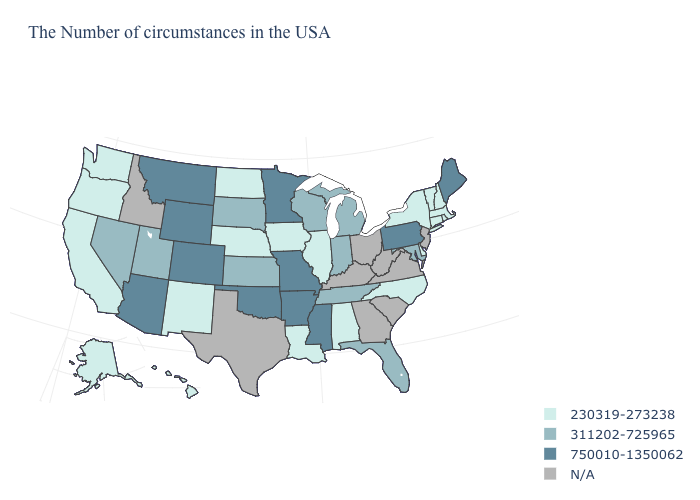Does Maine have the highest value in the Northeast?
Short answer required. Yes. What is the value of Maryland?
Give a very brief answer. 311202-725965. Name the states that have a value in the range 230319-273238?
Quick response, please. Massachusetts, Rhode Island, New Hampshire, Vermont, Connecticut, New York, Delaware, North Carolina, Alabama, Illinois, Louisiana, Iowa, Nebraska, North Dakota, New Mexico, California, Washington, Oregon, Alaska, Hawaii. Among the states that border Indiana , which have the lowest value?
Write a very short answer. Illinois. Does Nebraska have the lowest value in the MidWest?
Short answer required. Yes. Does Washington have the highest value in the West?
Short answer required. No. Name the states that have a value in the range N/A?
Short answer required. New Jersey, Virginia, South Carolina, West Virginia, Ohio, Georgia, Kentucky, Texas, Idaho. Which states have the lowest value in the USA?
Write a very short answer. Massachusetts, Rhode Island, New Hampshire, Vermont, Connecticut, New York, Delaware, North Carolina, Alabama, Illinois, Louisiana, Iowa, Nebraska, North Dakota, New Mexico, California, Washington, Oregon, Alaska, Hawaii. What is the value of Montana?
Be succinct. 750010-1350062. Among the states that border Oregon , which have the highest value?
Be succinct. Nevada. Name the states that have a value in the range 750010-1350062?
Quick response, please. Maine, Pennsylvania, Mississippi, Missouri, Arkansas, Minnesota, Oklahoma, Wyoming, Colorado, Montana, Arizona. What is the highest value in the USA?
Be succinct. 750010-1350062. Name the states that have a value in the range 750010-1350062?
Short answer required. Maine, Pennsylvania, Mississippi, Missouri, Arkansas, Minnesota, Oklahoma, Wyoming, Colorado, Montana, Arizona. Name the states that have a value in the range 230319-273238?
Answer briefly. Massachusetts, Rhode Island, New Hampshire, Vermont, Connecticut, New York, Delaware, North Carolina, Alabama, Illinois, Louisiana, Iowa, Nebraska, North Dakota, New Mexico, California, Washington, Oregon, Alaska, Hawaii. 